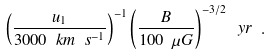Convert formula to latex. <formula><loc_0><loc_0><loc_500><loc_500>\left ( \frac { u _ { 1 } } { 3 0 0 0 \ k m \ s ^ { - 1 } } \right ) ^ { - 1 } \left ( \frac { B } { 1 0 0 \ \mu G } \right ) ^ { - 3 / 2 } \ y r \ .</formula> 